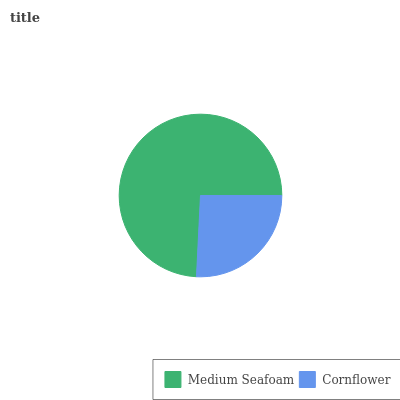Is Cornflower the minimum?
Answer yes or no. Yes. Is Medium Seafoam the maximum?
Answer yes or no. Yes. Is Cornflower the maximum?
Answer yes or no. No. Is Medium Seafoam greater than Cornflower?
Answer yes or no. Yes. Is Cornflower less than Medium Seafoam?
Answer yes or no. Yes. Is Cornflower greater than Medium Seafoam?
Answer yes or no. No. Is Medium Seafoam less than Cornflower?
Answer yes or no. No. Is Medium Seafoam the high median?
Answer yes or no. Yes. Is Cornflower the low median?
Answer yes or no. Yes. Is Cornflower the high median?
Answer yes or no. No. Is Medium Seafoam the low median?
Answer yes or no. No. 